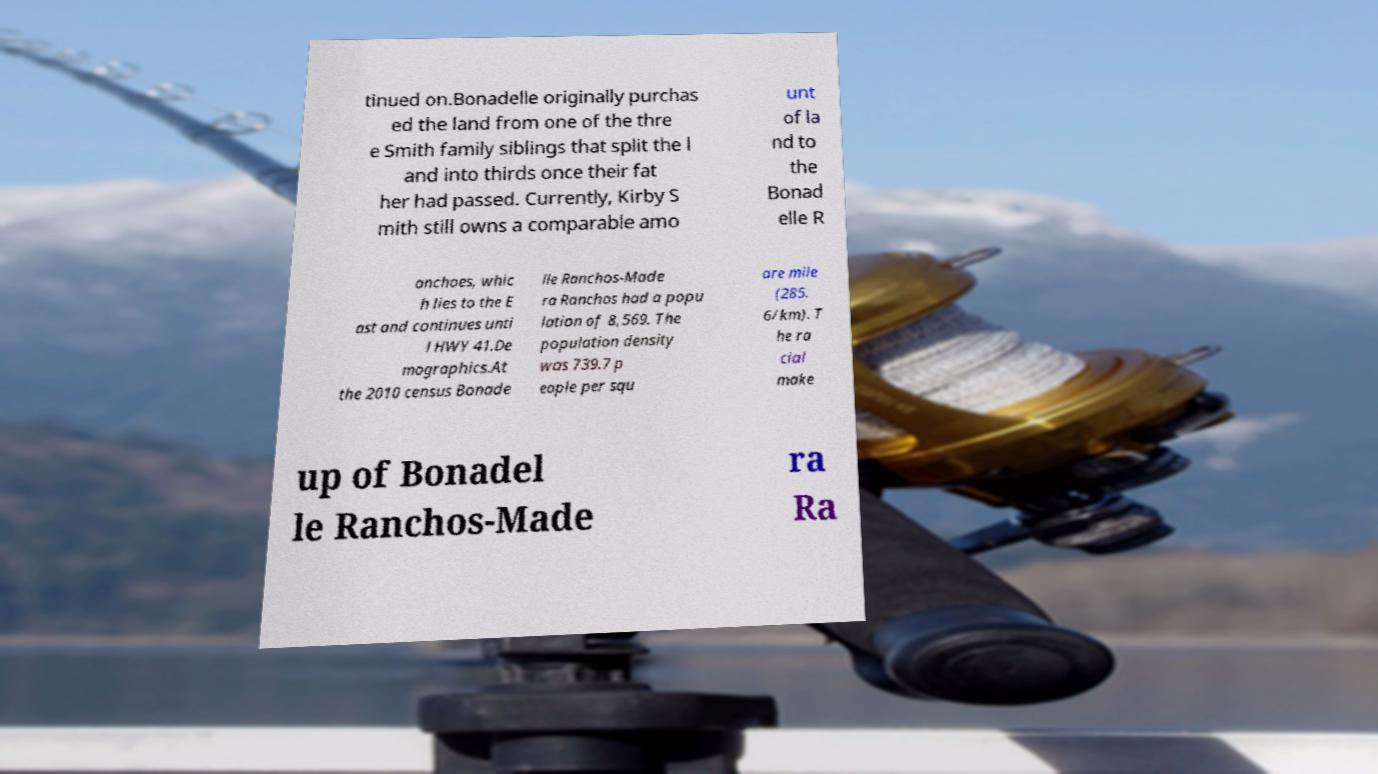Could you assist in decoding the text presented in this image and type it out clearly? tinued on.Bonadelle originally purchas ed the land from one of the thre e Smith family siblings that split the l and into thirds once their fat her had passed. Currently, Kirby S mith still owns a comparable amo unt of la nd to the Bonad elle R anchoes, whic h lies to the E ast and continues unti l HWY 41.De mographics.At the 2010 census Bonade lle Ranchos-Made ra Ranchos had a popu lation of 8,569. The population density was 739.7 p eople per squ are mile (285. 6/km). T he ra cial make up of Bonadel le Ranchos-Made ra Ra 